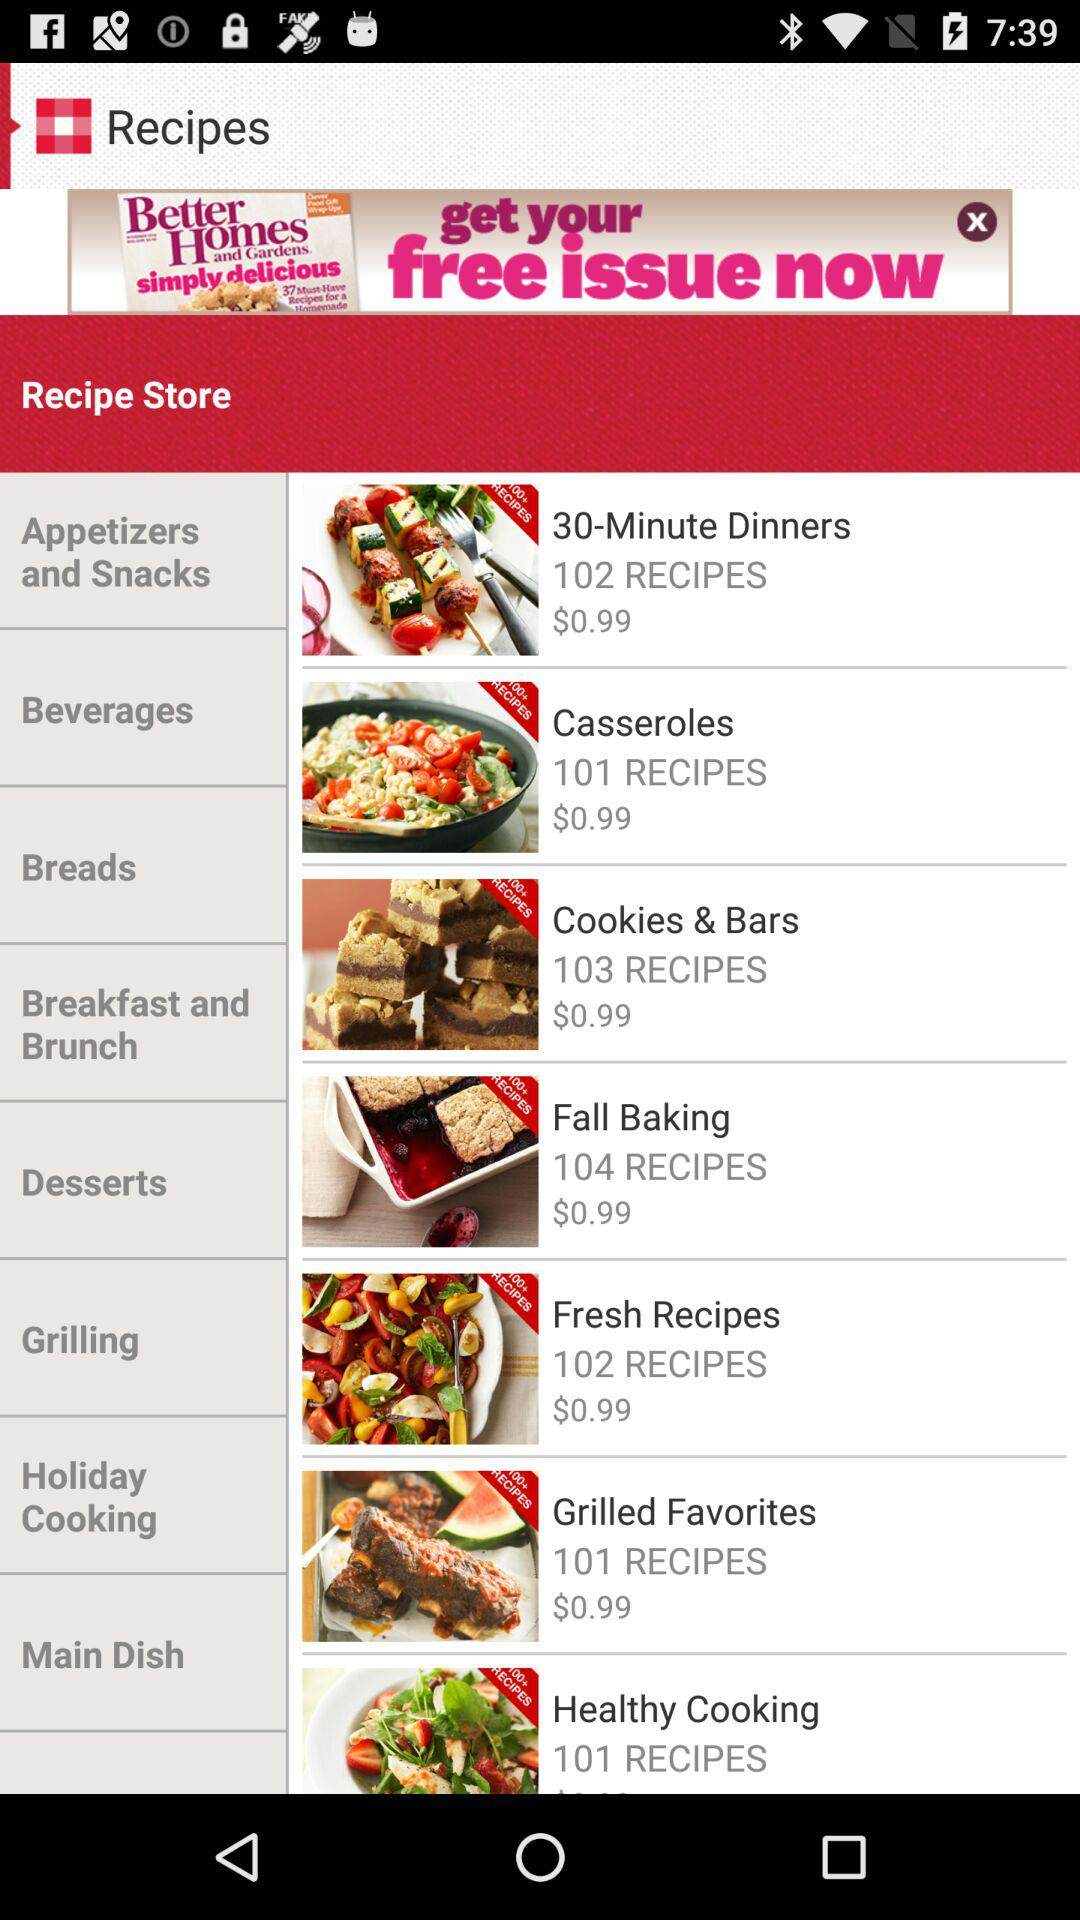What is the price of "Casseroles"? The price of "Casseroles" is $0.99. 